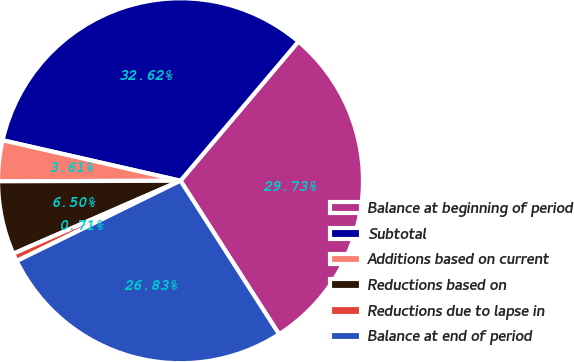Convert chart. <chart><loc_0><loc_0><loc_500><loc_500><pie_chart><fcel>Balance at beginning of period<fcel>Subtotal<fcel>Additions based on current<fcel>Reductions based on<fcel>Reductions due to lapse in<fcel>Balance at end of period<nl><fcel>29.73%<fcel>32.62%<fcel>3.61%<fcel>6.5%<fcel>0.71%<fcel>26.83%<nl></chart> 